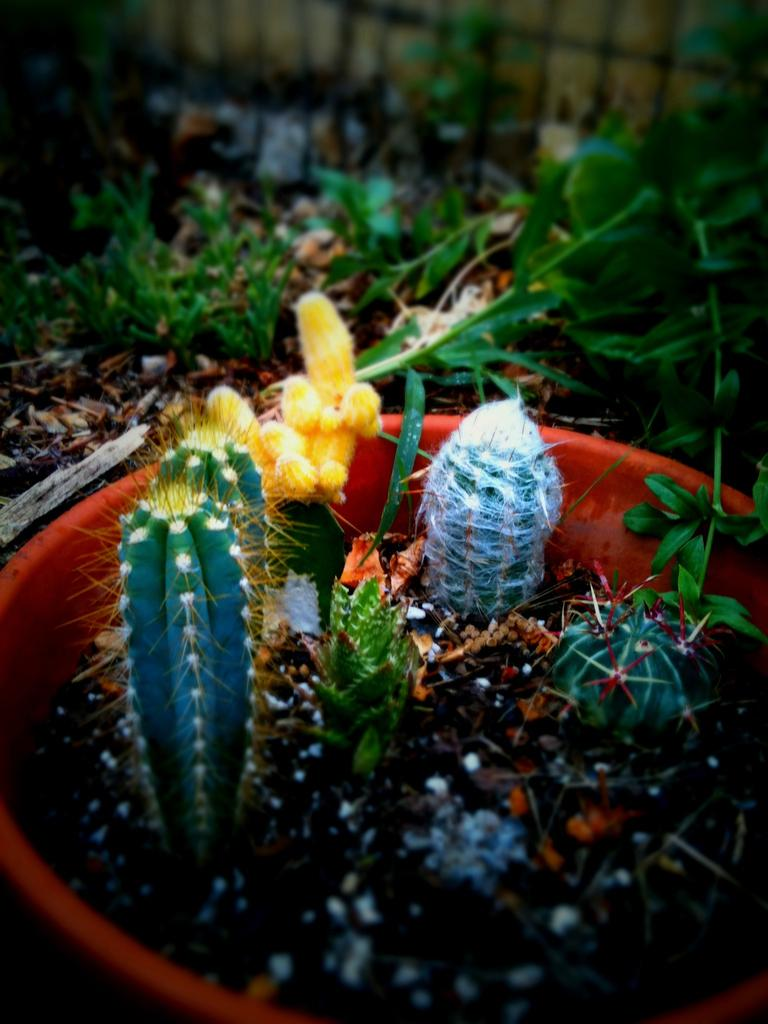What type of plants are in the pot in the image? There are cactus plants in a pot in the image. What other types of plants are visible in the image? There are other plants in the image. What can be seen in the background of the image? There is a wall in the background of the image. How does the sheet affect the growth of the cactus plants in the image? There is no sheet present in the image, so it cannot affect the growth of the cactus plants. 